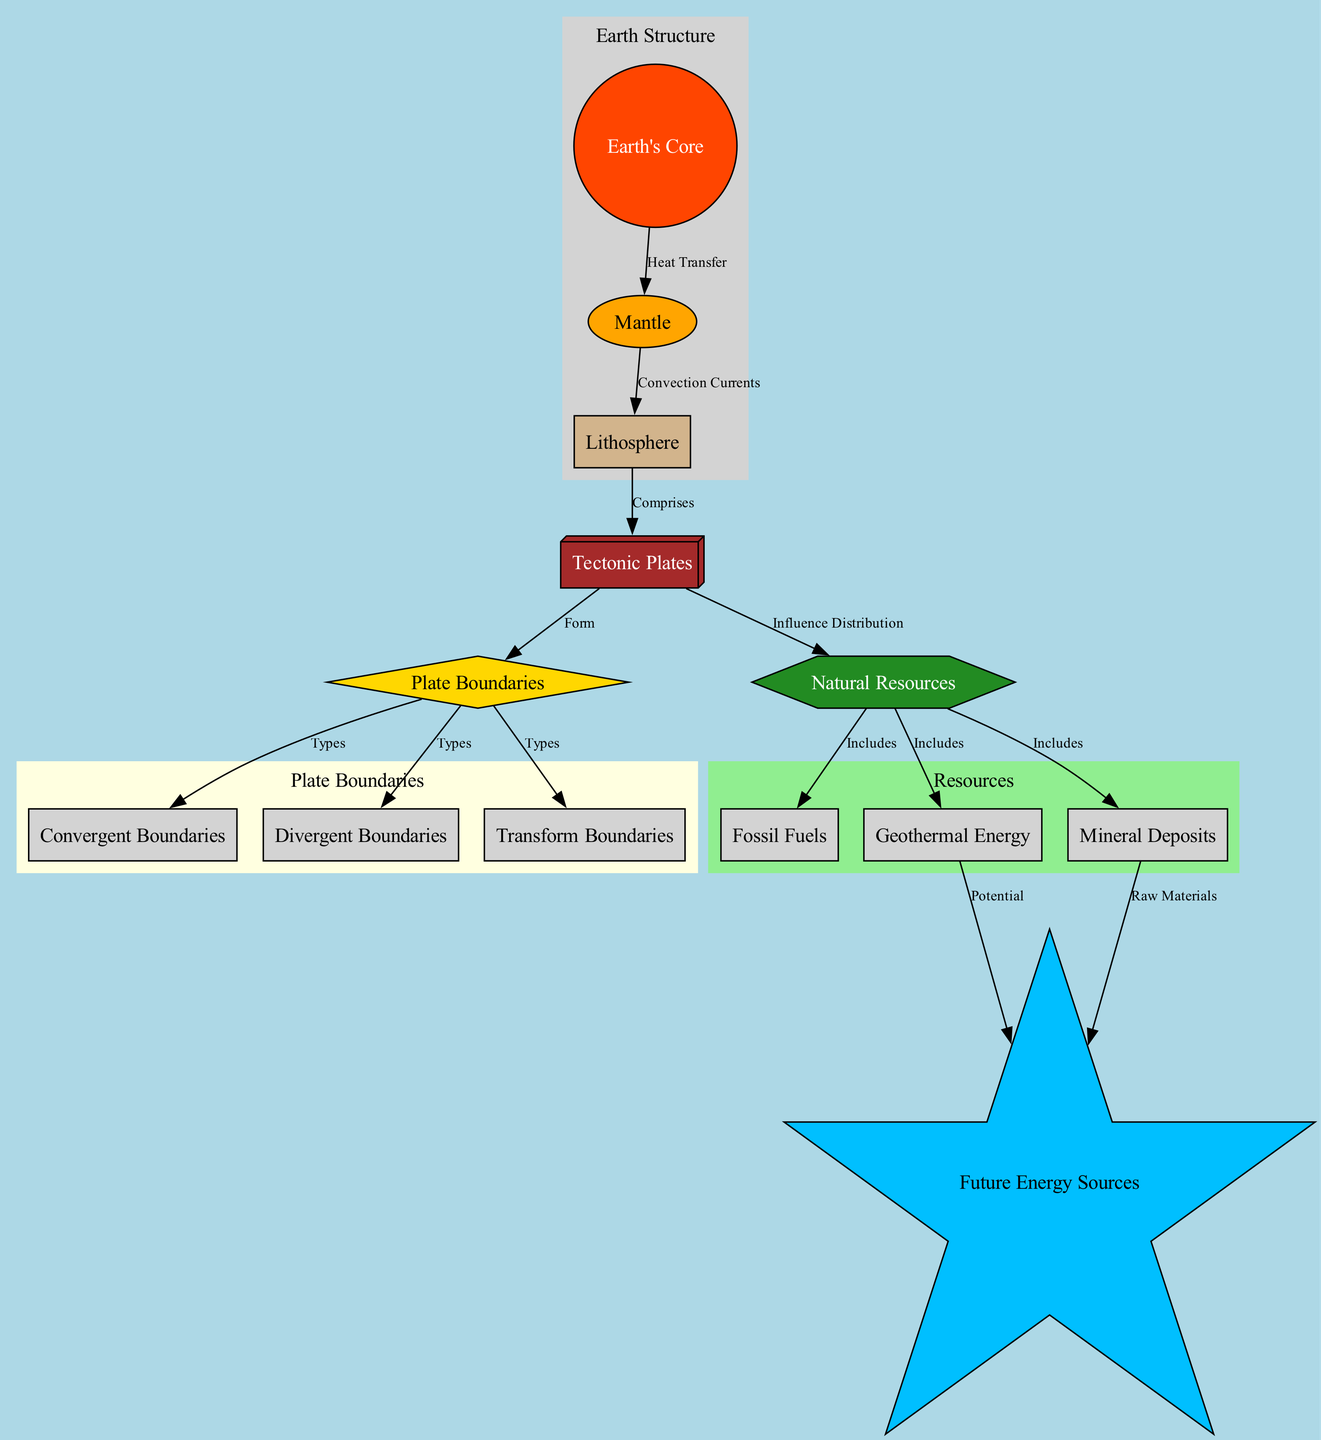What are the types of plate boundaries? The diagram indicates three types of plate boundaries: convergent, divergent, and transform, which are all labeled as types under the plate boundaries node.
Answer: Convergent, divergent, transform How many natural resources are indicated in the diagram? The diagram lists three natural resources: fossil fuels, geothermal energy, and mineral deposits, which can be counted directly from the natural resources node.
Answer: Three What is the relationship between tectonic plates and natural resources? The diagram shows a clear influence from tectonic plates to natural resources, implying that tectonic plate movements affect the distribution of these resources.
Answer: Influence Distribution Which layer of the Earth comprises the tectonic plates? The lithosphere is indicated as comprising the tectonic plates, which is stated in the relationship labeled as "Comprises" connecting the lithosphere to the tectonic plates node.
Answer: Lithosphere What potential future energy source is connected to geothermal energy in the diagram? The diagram shows a direct connection labeled "Potential" from geothermal energy to future energy sources, indicating that geothermal energy could be a source for future energy.
Answer: Future Energy Sources How does heat transfer from the Earth's core to the mantle? The diagram labels the relationship between the Earth's core and mantle as "Heat Transfer," demonstrating a direct flow of heat from the core to the mantle.
Answer: Heat Transfer What node represents raw materials for future energy sources? The diagram indicates that mineral deposits are the raw materials that contribute to future energy sources, as shown in the relationship labeled "Raw Materials."
Answer: Mineral Deposits Which layer provides convection currents to the lithosphere? The mantle is shown to provide convection currents to the lithosphere, as indicated in the relationship labeled "Convection Currents."
Answer: Mantle What color represents the node for fossil fuels in the diagram? The fossil fuels node is filled with the color associated with natural resources, which is forest green according to the node styles provided in the diagram.
Answer: Forest Green 